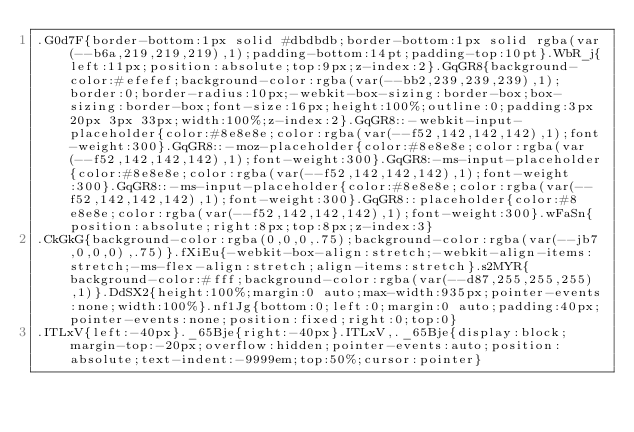<code> <loc_0><loc_0><loc_500><loc_500><_CSS_>.G0d7F{border-bottom:1px solid #dbdbdb;border-bottom:1px solid rgba(var(--b6a,219,219,219),1);padding-bottom:14pt;padding-top:10pt}.WbR_j{left:11px;position:absolute;top:9px;z-index:2}.GqGR8{background-color:#efefef;background-color:rgba(var(--bb2,239,239,239),1);border:0;border-radius:10px;-webkit-box-sizing:border-box;box-sizing:border-box;font-size:16px;height:100%;outline:0;padding:3px 20px 3px 33px;width:100%;z-index:2}.GqGR8::-webkit-input-placeholder{color:#8e8e8e;color:rgba(var(--f52,142,142,142),1);font-weight:300}.GqGR8::-moz-placeholder{color:#8e8e8e;color:rgba(var(--f52,142,142,142),1);font-weight:300}.GqGR8:-ms-input-placeholder{color:#8e8e8e;color:rgba(var(--f52,142,142,142),1);font-weight:300}.GqGR8::-ms-input-placeholder{color:#8e8e8e;color:rgba(var(--f52,142,142,142),1);font-weight:300}.GqGR8::placeholder{color:#8e8e8e;color:rgba(var(--f52,142,142,142),1);font-weight:300}.wFaSn{position:absolute;right:8px;top:8px;z-index:3}
.CkGkG{background-color:rgba(0,0,0,.75);background-color:rgba(var(--jb7,0,0,0),.75)}.fXiEu{-webkit-box-align:stretch;-webkit-align-items:stretch;-ms-flex-align:stretch;align-items:stretch}.s2MYR{background-color:#fff;background-color:rgba(var(--d87,255,255,255),1)}.DdSX2{height:100%;margin:0 auto;max-width:935px;pointer-events:none;width:100%}.nf1Jg{bottom:0;left:0;margin:0 auto;padding:40px;pointer-events:none;position:fixed;right:0;top:0}
.ITLxV{left:-40px}._65Bje{right:-40px}.ITLxV,._65Bje{display:block;margin-top:-20px;overflow:hidden;pointer-events:auto;position:absolute;text-indent:-9999em;top:50%;cursor:pointer}</code> 